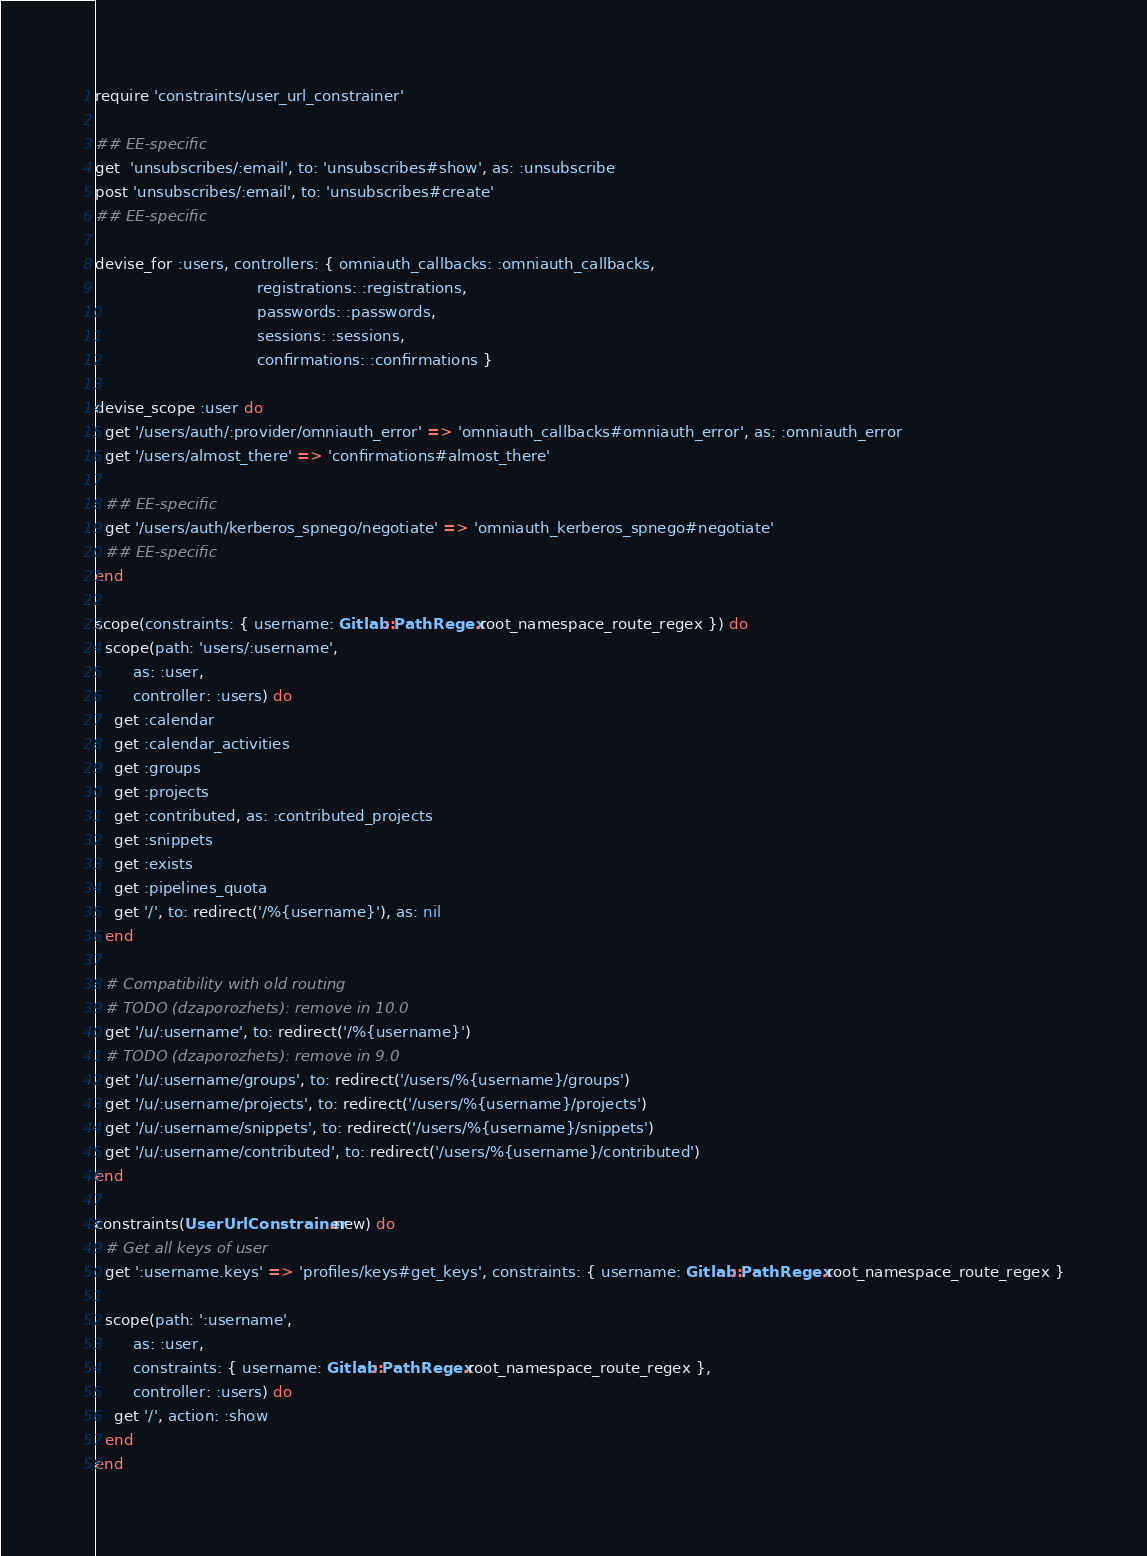Convert code to text. <code><loc_0><loc_0><loc_500><loc_500><_Ruby_>require 'constraints/user_url_constrainer'

## EE-specific
get  'unsubscribes/:email', to: 'unsubscribes#show', as: :unsubscribe
post 'unsubscribes/:email', to: 'unsubscribes#create'
## EE-specific

devise_for :users, controllers: { omniauth_callbacks: :omniauth_callbacks,
                                  registrations: :registrations,
                                  passwords: :passwords,
                                  sessions: :sessions,
                                  confirmations: :confirmations }

devise_scope :user do
  get '/users/auth/:provider/omniauth_error' => 'omniauth_callbacks#omniauth_error', as: :omniauth_error
  get '/users/almost_there' => 'confirmations#almost_there'

  ## EE-specific
  get '/users/auth/kerberos_spnego/negotiate' => 'omniauth_kerberos_spnego#negotiate'
  ## EE-specific
end

scope(constraints: { username: Gitlab::PathRegex.root_namespace_route_regex }) do
  scope(path: 'users/:username',
        as: :user,
        controller: :users) do
    get :calendar
    get :calendar_activities
    get :groups
    get :projects
    get :contributed, as: :contributed_projects
    get :snippets
    get :exists
    get :pipelines_quota
    get '/', to: redirect('/%{username}'), as: nil
  end

  # Compatibility with old routing
  # TODO (dzaporozhets): remove in 10.0
  get '/u/:username', to: redirect('/%{username}')
  # TODO (dzaporozhets): remove in 9.0
  get '/u/:username/groups', to: redirect('/users/%{username}/groups')
  get '/u/:username/projects', to: redirect('/users/%{username}/projects')
  get '/u/:username/snippets', to: redirect('/users/%{username}/snippets')
  get '/u/:username/contributed', to: redirect('/users/%{username}/contributed')
end

constraints(UserUrlConstrainer.new) do
  # Get all keys of user
  get ':username.keys' => 'profiles/keys#get_keys', constraints: { username: Gitlab::PathRegex.root_namespace_route_regex }

  scope(path: ':username',
        as: :user,
        constraints: { username: Gitlab::PathRegex.root_namespace_route_regex },
        controller: :users) do
    get '/', action: :show
  end
end
</code> 